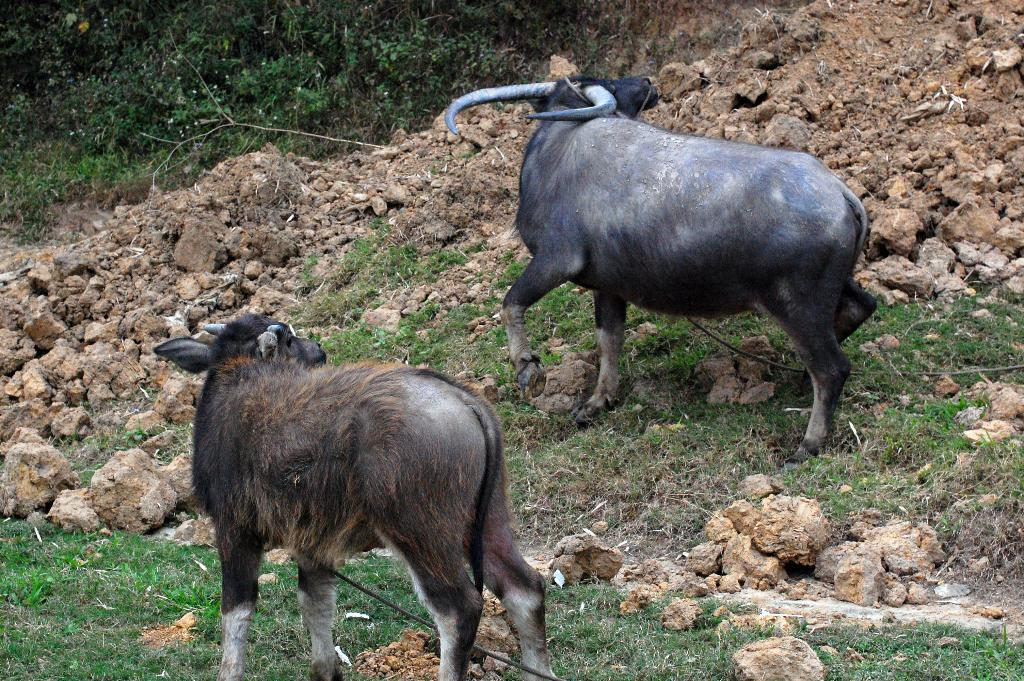How many buffaloes are in the image? There are two buffaloes in the image. What is at the bottom of the image? There is grass at the bottom of the image. What else can be seen in the image besides the buffaloes and grass? There are rocks visible in the image. Where is the kitty seeking comfort in the image? There is no kitty present in the image. What type of cast is visible on the buffalo's leg in the image? There is no cast visible on any of the buffaloes' legs in the image. 